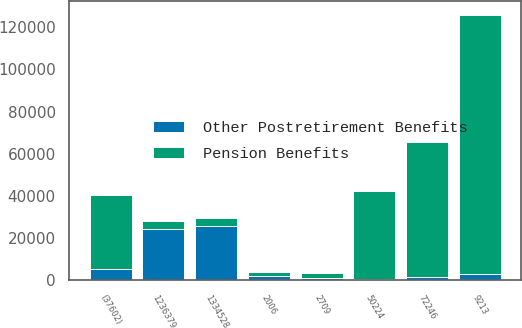Convert chart to OTSL. <chart><loc_0><loc_0><loc_500><loc_500><stacked_bar_chart><ecel><fcel>2006<fcel>1236379<fcel>50224<fcel>72246<fcel>2709<fcel>9213<fcel>(37602)<fcel>1334528<nl><fcel>Pension Benefits<fcel>2005<fcel>4052.5<fcel>41910<fcel>64102<fcel>2446<fcel>123140<fcel>35010<fcel>4052.5<nl><fcel>Other Postretirement Benefits<fcel>2006<fcel>24267<fcel>475<fcel>1327<fcel>1173<fcel>2842<fcel>5263<fcel>25669<nl></chart> 